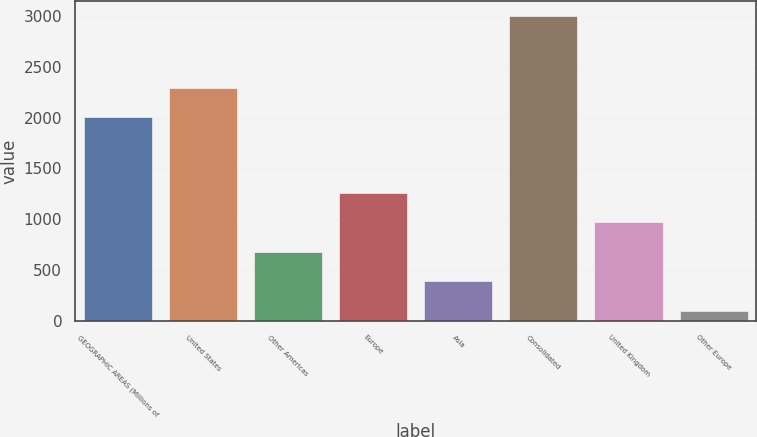Convert chart. <chart><loc_0><loc_0><loc_500><loc_500><bar_chart><fcel>GEOGRAPHIC AREAS (Millions of<fcel>United States<fcel>Other Americas<fcel>Europe<fcel>Asia<fcel>Consolidated<fcel>United Kingdom<fcel>Other Europe<nl><fcel>2004<fcel>2293.44<fcel>681.88<fcel>1260.76<fcel>392.44<fcel>2997.4<fcel>971.32<fcel>103<nl></chart> 